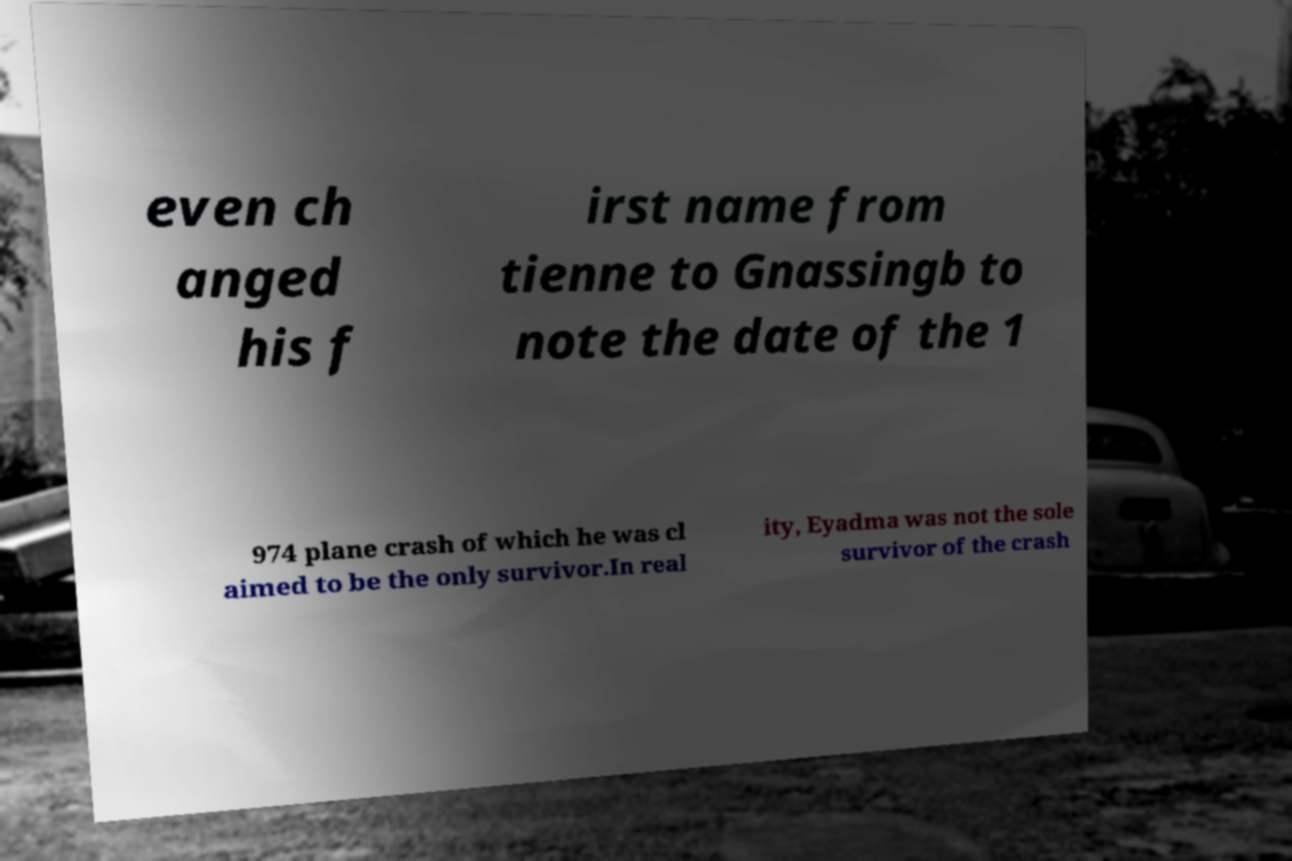Can you accurately transcribe the text from the provided image for me? even ch anged his f irst name from tienne to Gnassingb to note the date of the 1 974 plane crash of which he was cl aimed to be the only survivor.In real ity, Eyadma was not the sole survivor of the crash 